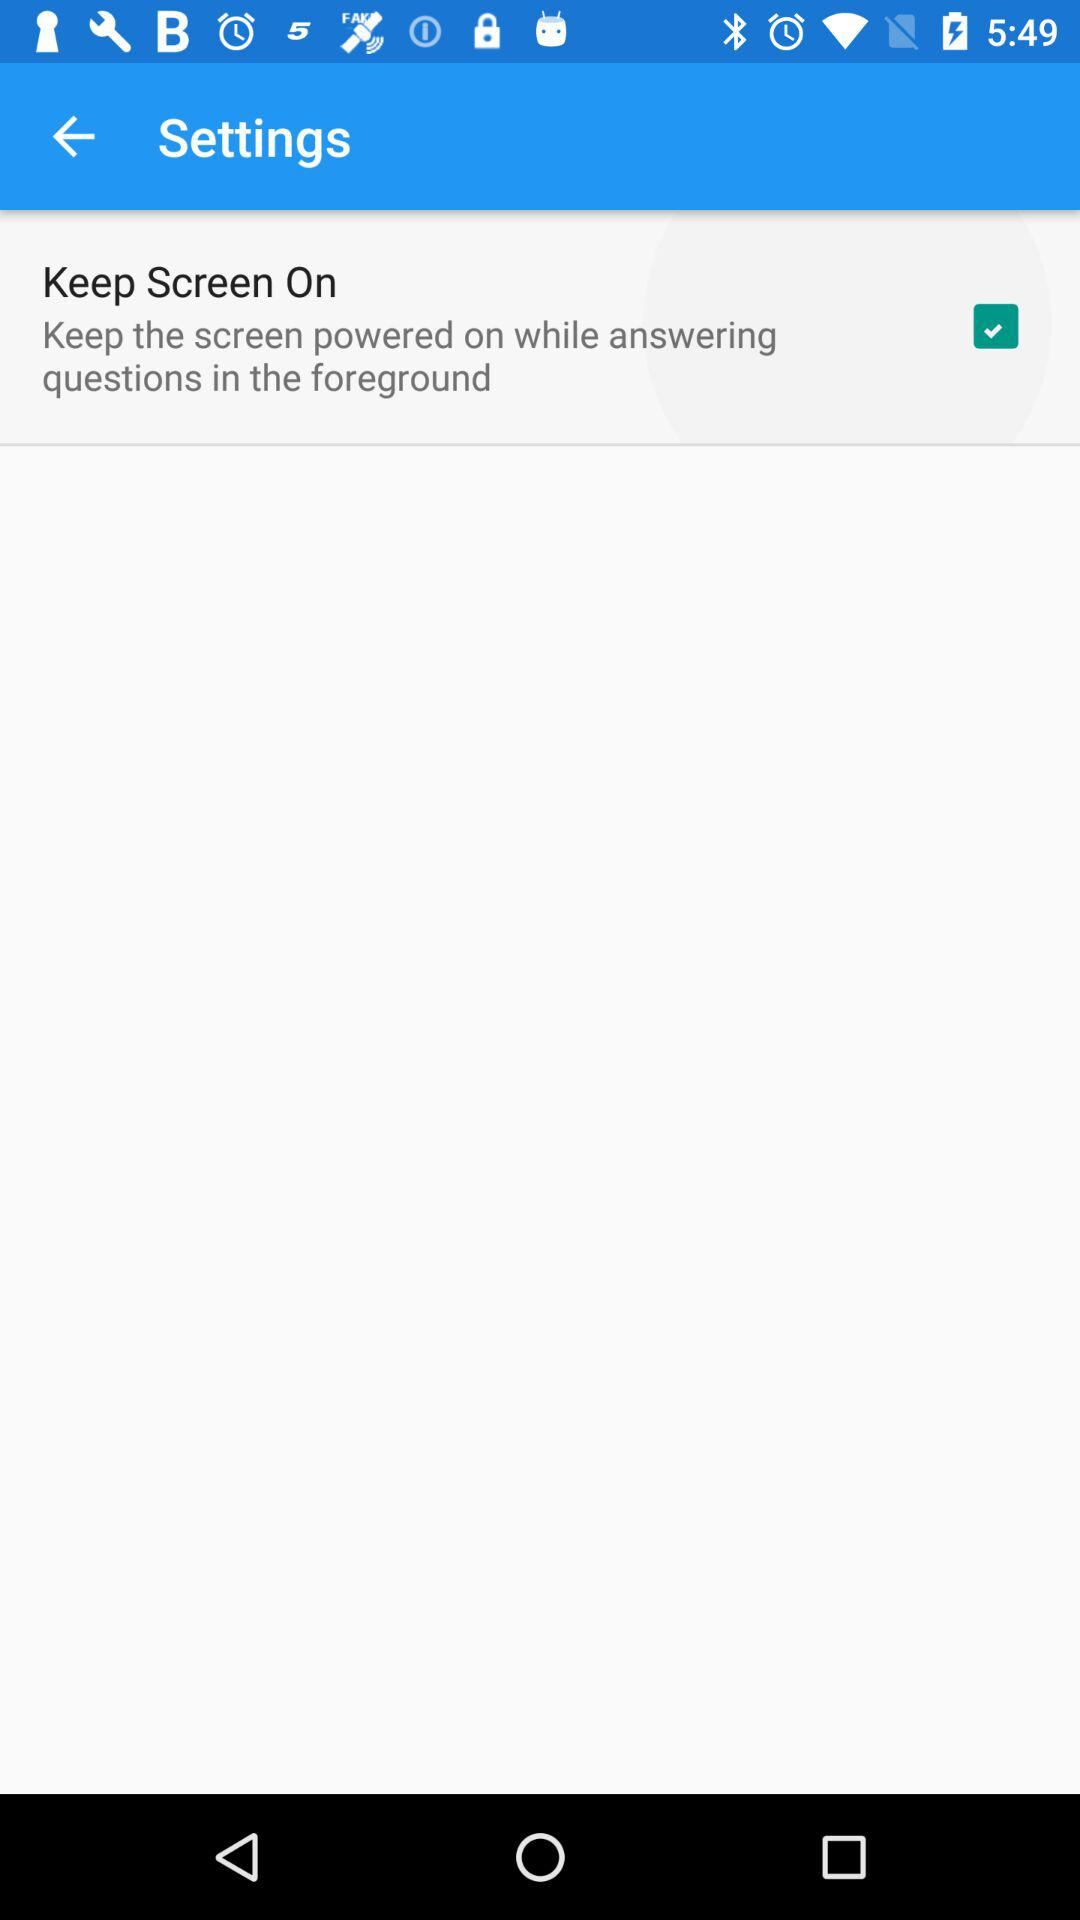What is the name of the application?
When the provided information is insufficient, respond with <no answer>. <no answer> 